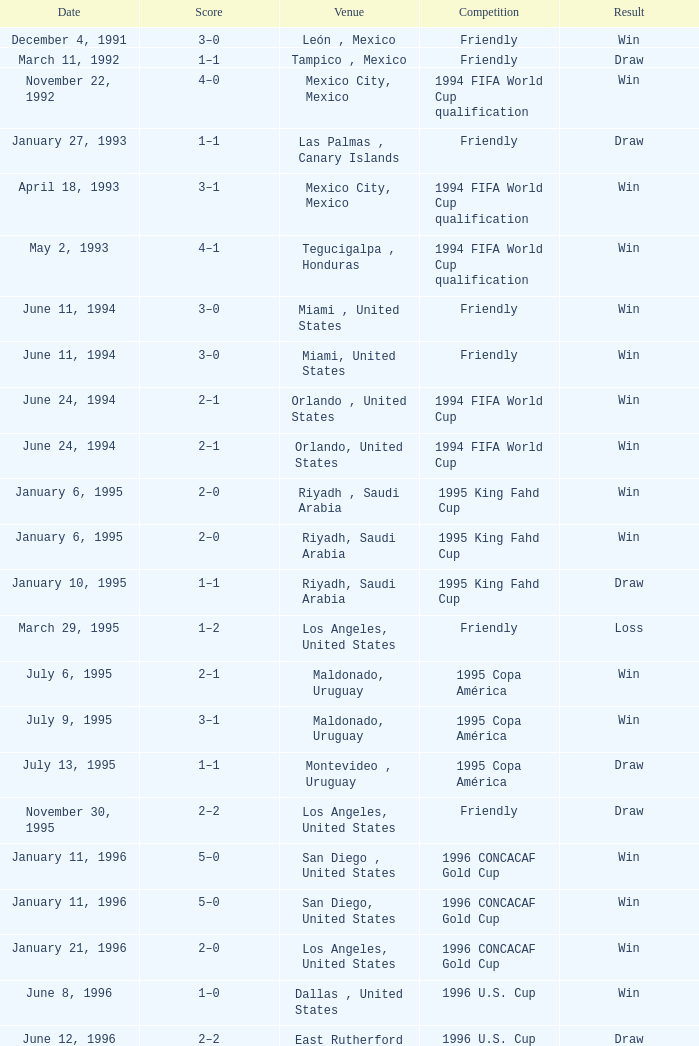What is Score, when Venue is Riyadh, Saudi Arabia, and when Result is "Win"? 2–0, 2–0. 